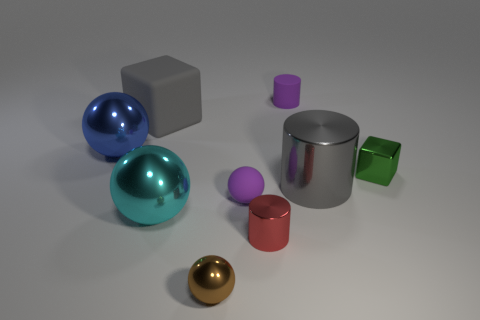Add 1 gray objects. How many objects exist? 10 Subtract all cylinders. How many objects are left? 6 Subtract all matte cylinders. Subtract all yellow metal cylinders. How many objects are left? 8 Add 1 tiny green shiny cubes. How many tiny green shiny cubes are left? 2 Add 2 small brown metallic things. How many small brown metallic things exist? 3 Subtract 1 green cubes. How many objects are left? 8 